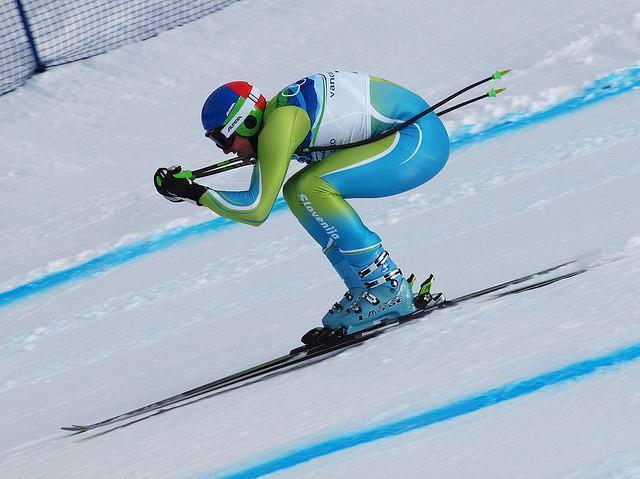What is this person trying to do?
Indicate the correct choice and explain in the format: 'Answer: answer
Rationale: rationale.'
Options: Roll, descend, flip, ascend. Answer: descend.
Rationale: They are headed rapidly down a steep hill. 